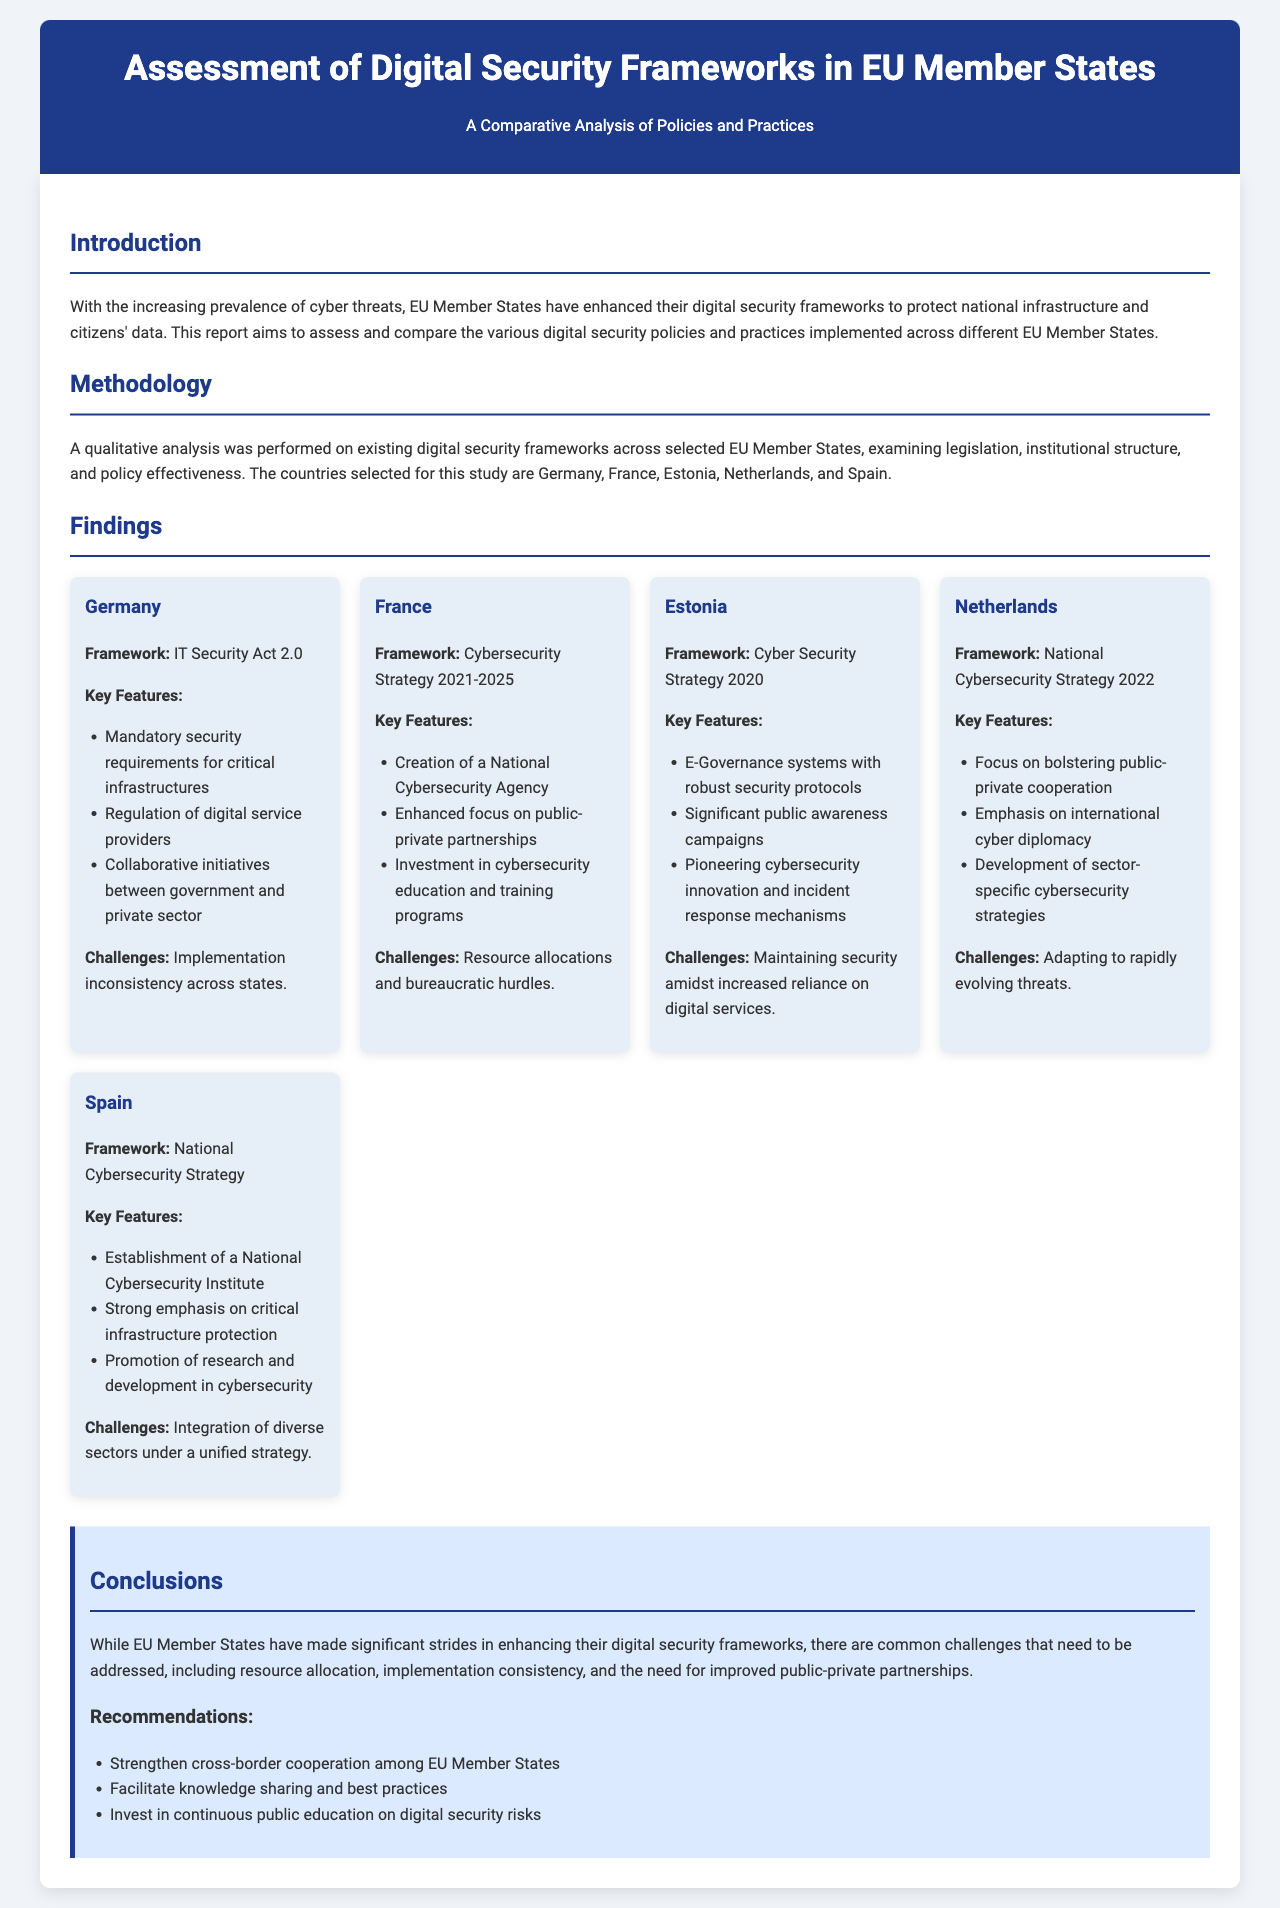What is the title of the report? The title of the report is presented in the header section of the document.
Answer: Assessment of Digital Security Frameworks in EU Member States Which country has the framework called IT Security Act 2.0? The framework name is specifically mentioned under Germany's section in the findings.
Answer: Germany What is a key feature of France's Cybersecurity Strategy 2021-2025? The key features include various elements; one is found in the features list for France.
Answer: Creation of a National Cybersecurity Agency What challenge is mentioned for Estonia? The challenges section outlines specific issues faced by Estonia, requiring reasoning from multiple findings.
Answer: Maintaining security amidst increased reliance on digital services How many countries are included in the comparative analysis? The number of countries selected for analysis is provided in the methodology section.
Answer: Five What is one of the recommendations stated in the conclusions? The recommendations list specific actions suggested after assessing the findings and challenges across countries.
Answer: Strengthen cross-border cooperation among EU Member States Which country emphasizes international cyber diplomacy in its strategy? The emphasis on international cyber diplomacy is clearly stated in the Netherlands' country card.
Answer: Netherlands What year does the Cyber Security Strategy for Estonia target? The year is part of the title provided in the findings section under Estonia.
Answer: 2020 